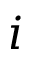Convert formula to latex. <formula><loc_0><loc_0><loc_500><loc_500>i</formula> 